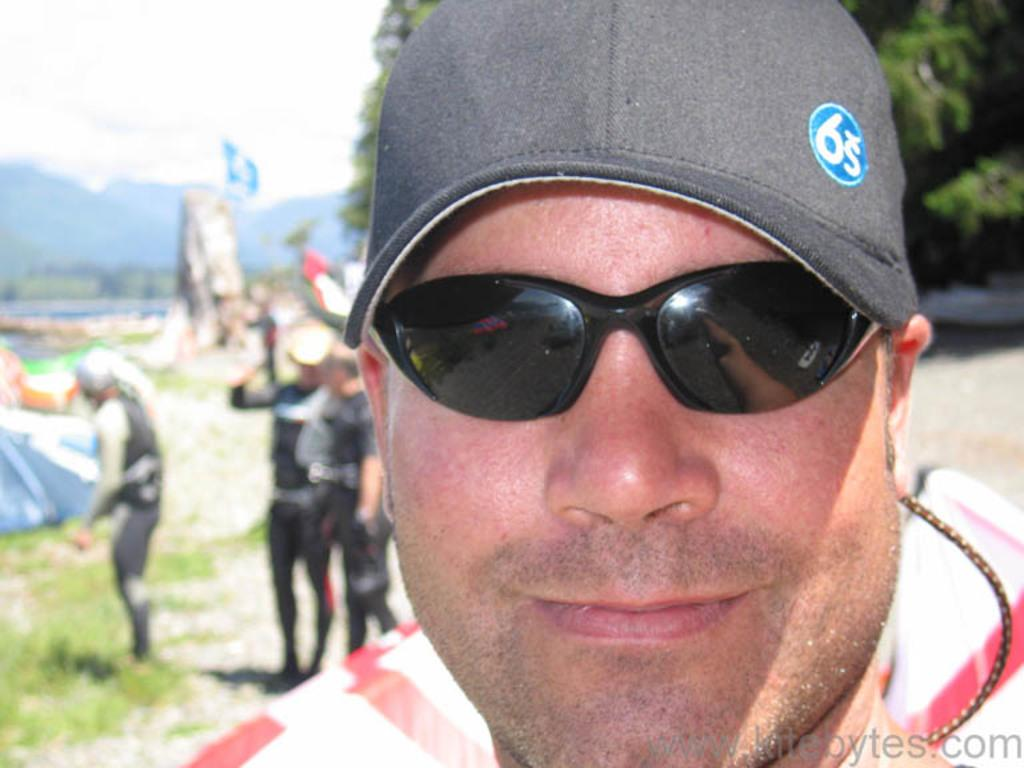What is the person in the image wearing on their head? The person is wearing a cap in the image. What type of eyewear is the person wearing? The person is wearing black goggles. Are there any other people present in the image? Yes, there are other people in the image. What can be seen in the background of the image? There are trees in the background of the image. How would you describe the background of the image? The background of the image is blurred. What type of leaf is the person holding in their hand in the image? There is no leaf present in the image; the person is wearing a cap and black goggles. Is the person wearing a scarf in the image? The provided facts do not mention a scarf, so we cannot determine if the person is wearing one. 